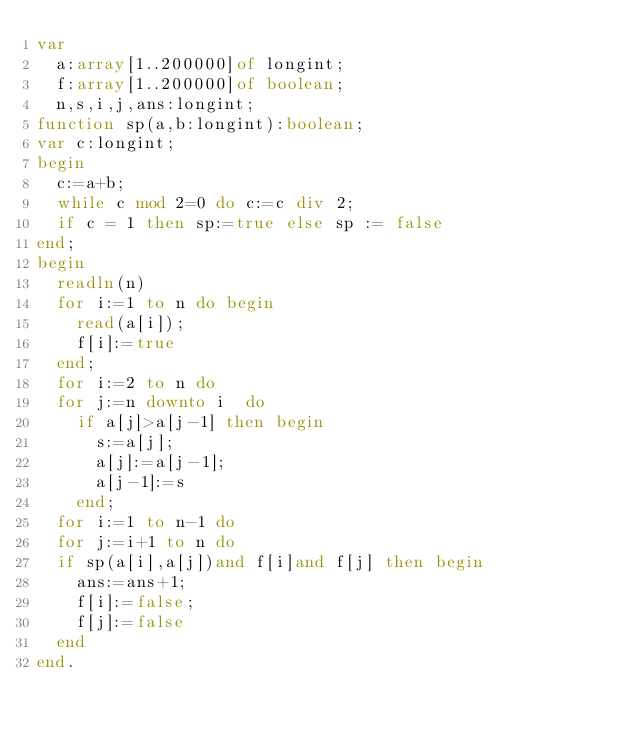Convert code to text. <code><loc_0><loc_0><loc_500><loc_500><_Pascal_>var
  a:array[1..200000]of longint;
  f:array[1..200000]of boolean;
  n,s,i,j,ans:longint;
function sp(a,b:longint):boolean;
var c:longint;
begin
  c:=a+b;
  while c mod 2=0 do c:=c div 2;
  if c = 1 then sp:=true else sp := false
end;
begin
  readln(n)
  for i:=1 to n do begin
    read(a[i]);
    f[i]:=true
  end;
  for i:=2 to n do
  for j:=n downto i  do
    if a[j]>a[j-1] then begin
      s:=a[j];
      a[j]:=a[j-1];
      a[j-1]:=s
    end;
  for i:=1 to n-1 do
  for j:=i+1 to n do
  if sp(a[i],a[j])and f[i]and f[j] then begin
    ans:=ans+1;
    f[i]:=false;
    f[j]:=false
  end
end.</code> 